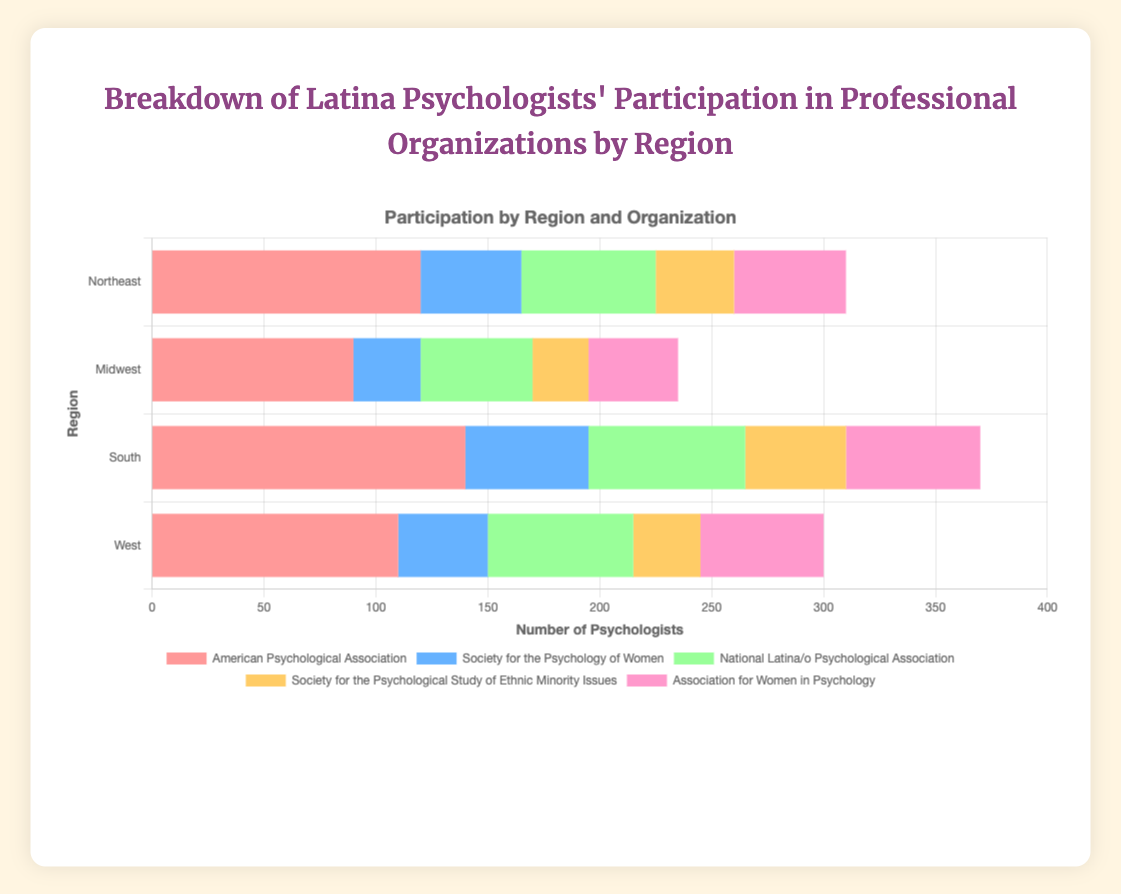What region has the highest participation in the American Psychological Association? The bar representing the South region is the longest among the bars for the American Psychological Association, indicating the highest participation.
Answer: South Comparing the Midwest and West, which region has more participants in the National Latina/o Psychological Association? The bar for the Midwest in the National Latina/o Psychological Association dataset is shorter than that for the West. This implies there are fewer participants in the Midwest.
Answer: West What is the total number of participants in the Society for the Psychological Study of Ethnic Minority Issues across all regions? Sum the participants for each region: 35 (Northeast) + 25 (Midwest) + 45 (South) + 30 (West). The total is 135.
Answer: 135 Which region has the least participation in the Society for the Psychology of Women? The Midwest has the shortest bar for the Society for the Psychology of Women, indicating it has the least participation in this organization.
Answer: Midwest What is the average number of participants in the American Psychological Association across all regions? Sum the participants in the American Psychological Association for all regions: 120 (Northeast) + 90 (Midwest) + 140 (South) + 110 (West) = 460. Then divide by 4 (the number of regions). The average is 460 / 4 = 115.
Answer: 115 How does the Northeast region's participation in the Association for Women in Psychology compare to the Midwest's? The bar for the Northeast (50) is longer than the bar for the Midwest (40) in the Association for Women in Psychology. Therefore, the Northeast has more participants.
Answer: Northeast Which organization has the most participants in the West region? The bar for the American Psychological Association is the longest in the West region, indicating it has the most participants.
Answer: American Psychological Association What is the difference in the number of participants between the South and the Northeast regions for the National Latina/o Psychological Association? The South has 70 participants and the Northeast has 60. The difference is 70 - 60 = 10.
Answer: 10 Which region has the overall lowest number of participants across all organizations? Sum the participants for each region:
Northeast: 310 (120 + 45 + 60 + 35 + 50),
Midwest: 235 (90 + 30 + 50 + 25 + 40),
South: 370 (140 + 55 + 70 + 45 + 60),
West: 300 (110 + 40 + 65 + 30 + 55).
The Midwest has the lowest sum of participants.
Answer: Midwest What's the ratio of participation in the Association for Women in Psychology between the South and the Northeast? Participation in the South is 60 and in the Northeast is 50. The ratio is 60:50, which simplifies to 6:5.
Answer: 6:5 